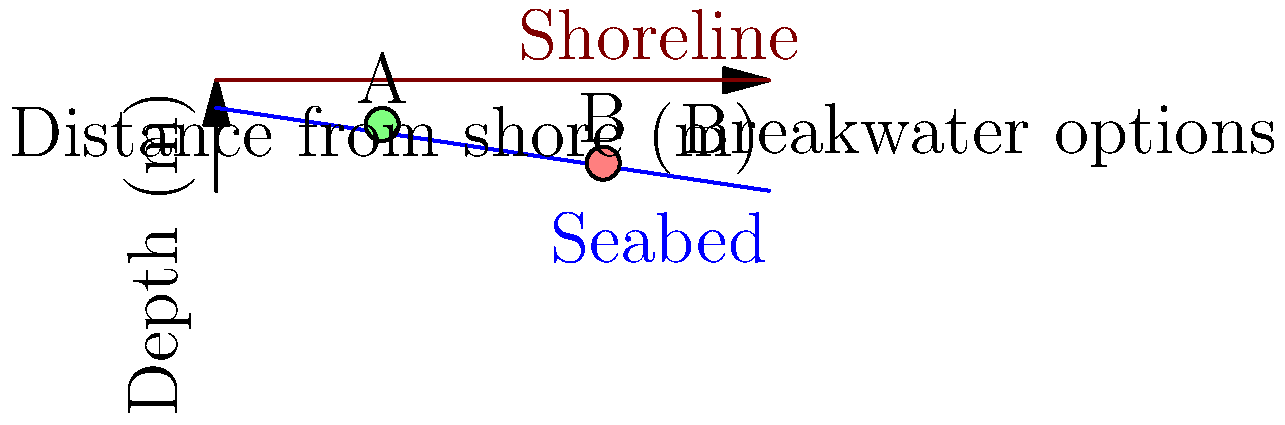Based on the coastal profile shown, which breakwater position (A or B) would be more effective in reducing erosion, and why? To determine the most effective breakwater position for reducing erosion, we need to consider several factors:

1. Water depth: Breakwaters are generally more effective in shallower water, as they can dissipate more wave energy.

2. Distance from shore: Breakwaters placed closer to the shore can provide more direct protection but may interfere with nearshore processes.

3. Wave breaking zone: The ideal location is often just seaward of the natural wave breaking zone.

4. Sediment transport: The breakwater should be positioned to minimize disruption to longshore sediment transport.

Analyzing the options:

A. Position A is located at approximately 30m from the shore and at a depth of about 8m.
B. Position B is located at approximately 70m from the shore and at a depth of about 15m.

Position A is more advantageous because:

1. It is in shallower water, allowing for more effective wave energy dissipation.
2. It is closer to the shore, providing more direct protection to the coastline.
3. It is likely positioned near the natural wave breaking zone, optimizing its effectiveness.
4. Its closer proximity to shore allows for better control of sediment transport processes.

While Position B might intercept larger waves earlier, its deeper location and greater distance from shore reduce its effectiveness in erosion control.
Answer: Position A 